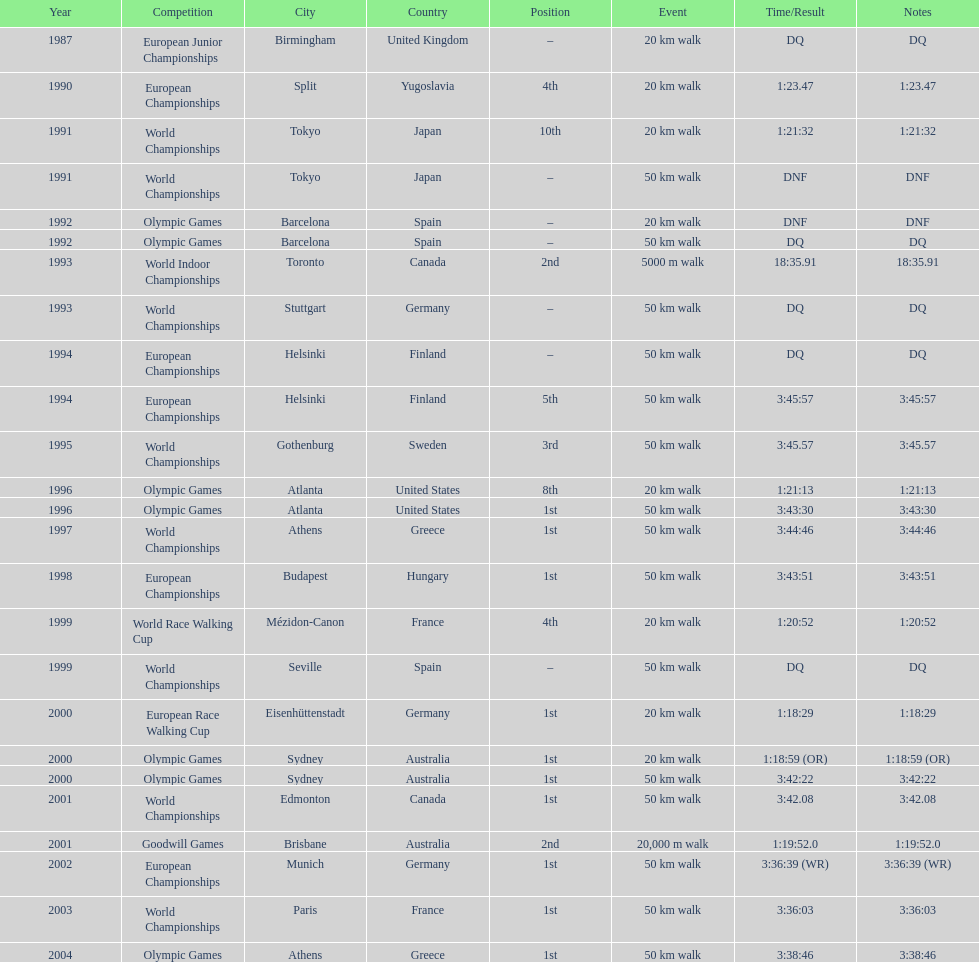In what year was korzeniowski's last competition? 2004. 